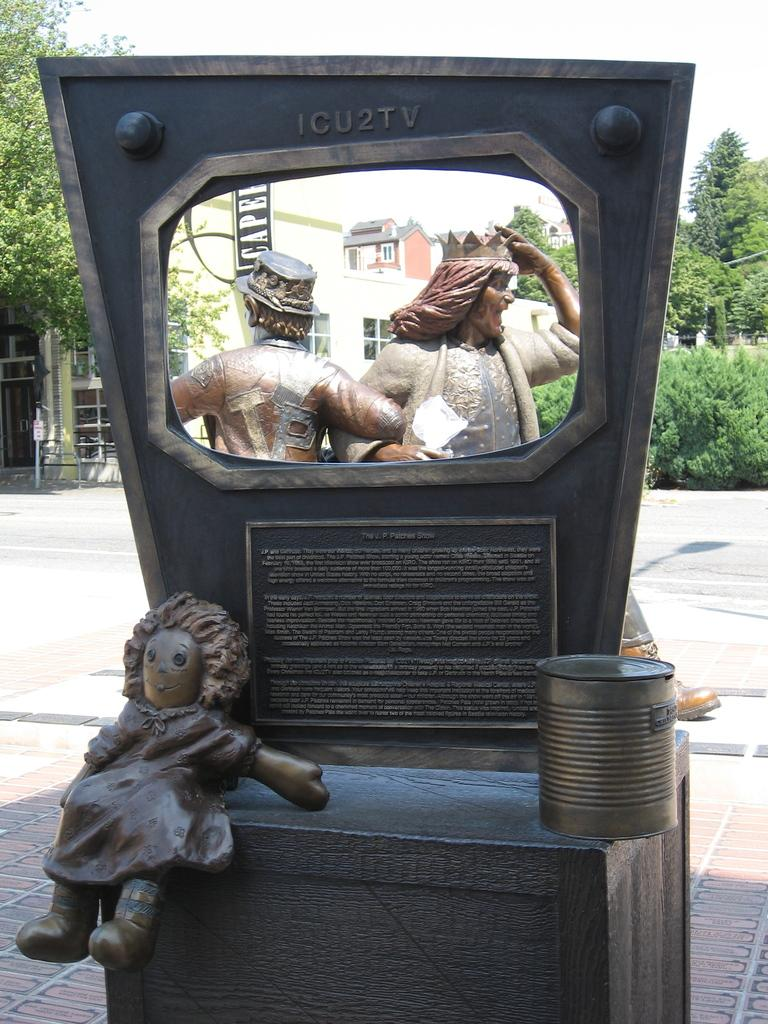What is the main subject in the center of the image? There are statues in the center of the image. What can be seen in the background of the image? There are trees and houses in the background of the image. What is at the bottom of the image? There is a road at the bottom of the image. What type of popcorn is being served to the babies in the image? There is no popcorn or babies present in the image. 